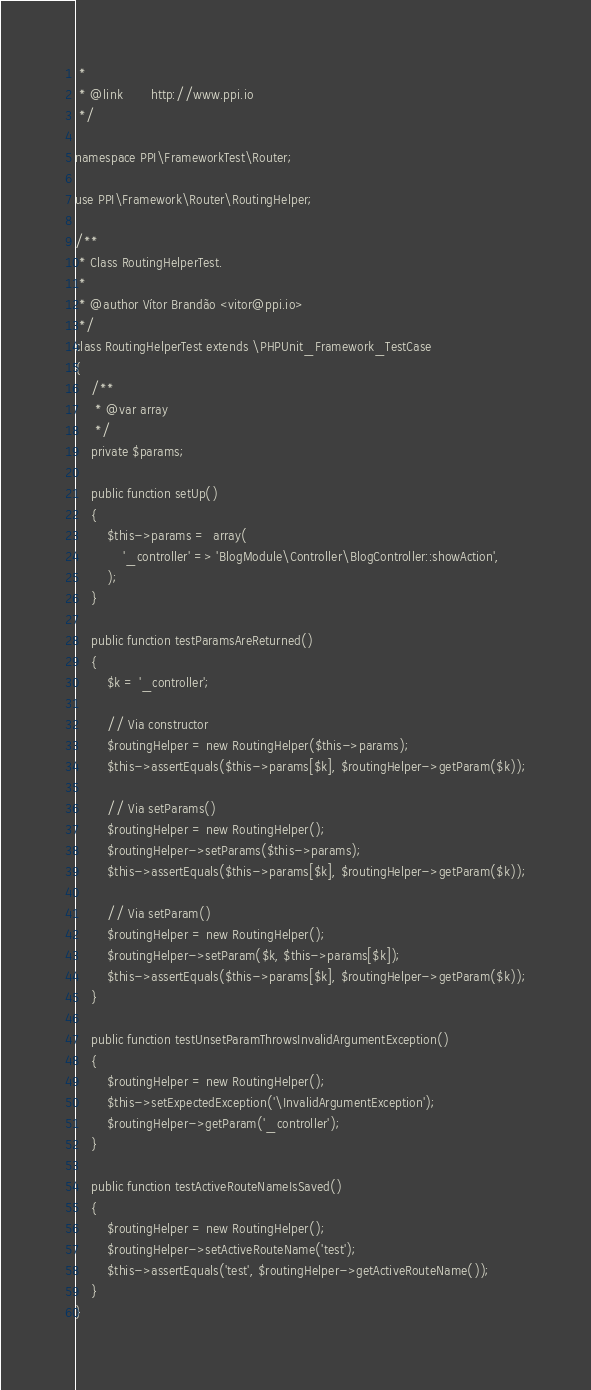<code> <loc_0><loc_0><loc_500><loc_500><_PHP_> *
 * @link       http://www.ppi.io
 */

namespace PPI\FrameworkTest\Router;

use PPI\Framework\Router\RoutingHelper;

/**
 * Class RoutingHelperTest.
 *
 * @author Vítor Brandão <vitor@ppi.io>
 */
class RoutingHelperTest extends \PHPUnit_Framework_TestCase
{
    /**
     * @var array
     */
    private $params;

    public function setUp()
    {
        $this->params =  array(
            '_controller' => 'BlogModule\Controller\BlogController::showAction',
        );
    }

    public function testParamsAreReturned()
    {
        $k = '_controller';

        // Via constructor
        $routingHelper = new RoutingHelper($this->params);
        $this->assertEquals($this->params[$k], $routingHelper->getParam($k));

        // Via setParams()
        $routingHelper = new RoutingHelper();
        $routingHelper->setParams($this->params);
        $this->assertEquals($this->params[$k], $routingHelper->getParam($k));

        // Via setParam()
        $routingHelper = new RoutingHelper();
        $routingHelper->setParam($k, $this->params[$k]);
        $this->assertEquals($this->params[$k], $routingHelper->getParam($k));
    }

    public function testUnsetParamThrowsInvalidArgumentException()
    {
        $routingHelper = new RoutingHelper();
        $this->setExpectedException('\InvalidArgumentException');
        $routingHelper->getParam('_controller');
    }

    public function testActiveRouteNameIsSaved()
    {
        $routingHelper = new RoutingHelper();
        $routingHelper->setActiveRouteName('test');
        $this->assertEquals('test', $routingHelper->getActiveRouteName());
    }
}
</code> 